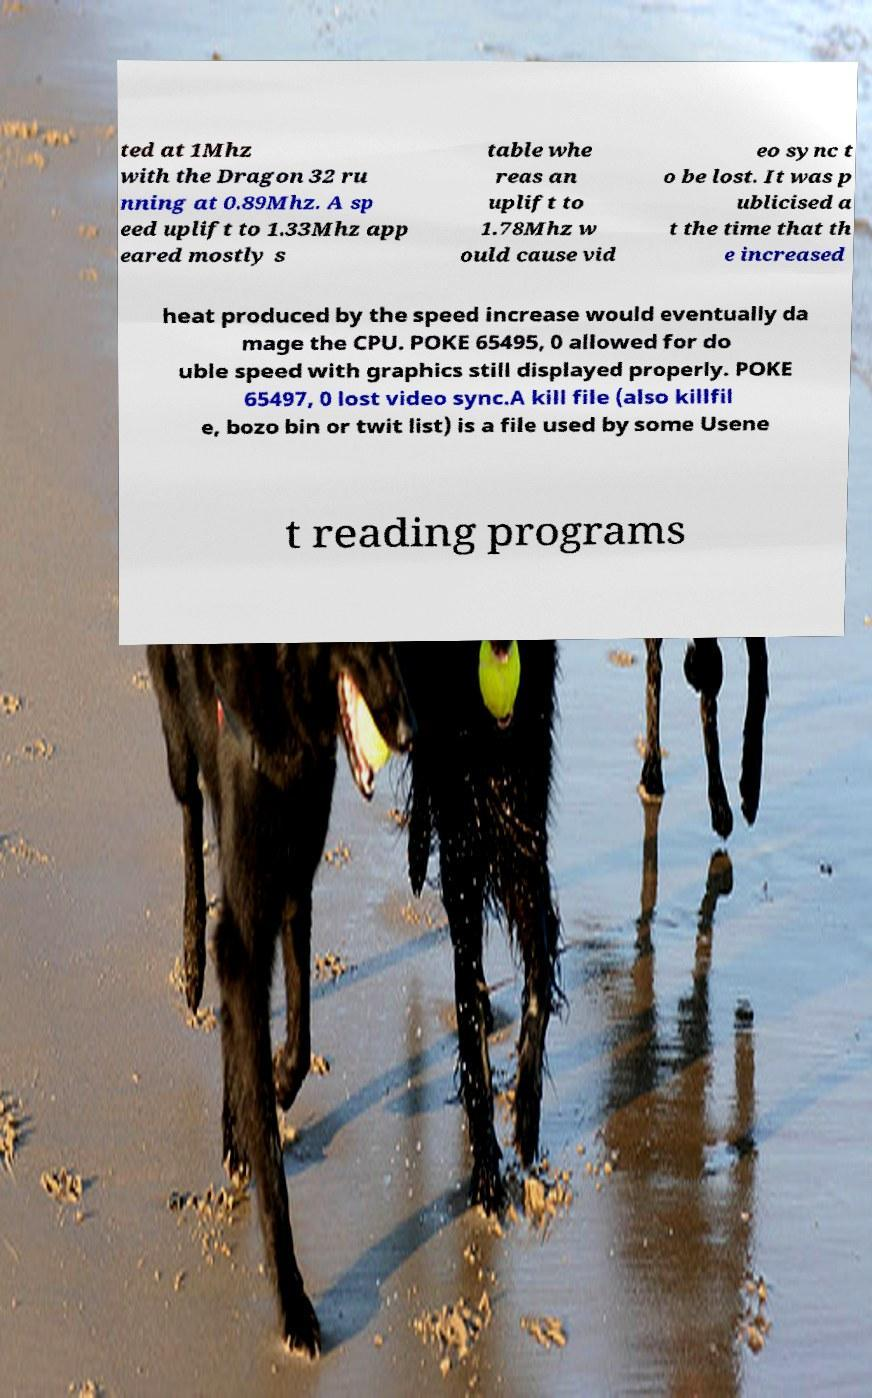Can you accurately transcribe the text from the provided image for me? ted at 1Mhz with the Dragon 32 ru nning at 0.89Mhz. A sp eed uplift to 1.33Mhz app eared mostly s table whe reas an uplift to 1.78Mhz w ould cause vid eo sync t o be lost. It was p ublicised a t the time that th e increased heat produced by the speed increase would eventually da mage the CPU. POKE 65495, 0 allowed for do uble speed with graphics still displayed properly. POKE 65497, 0 lost video sync.A kill file (also killfil e, bozo bin or twit list) is a file used by some Usene t reading programs 